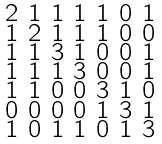Convert formula to latex. <formula><loc_0><loc_0><loc_500><loc_500>\begin{smallmatrix} 2 & 1 & 1 & 1 & 1 & 0 & 1 \\ 1 & 2 & 1 & 1 & 1 & 0 & 0 \\ 1 & 1 & 3 & 1 & 0 & 0 & 1 \\ 1 & 1 & 1 & 3 & 0 & 0 & 1 \\ 1 & 1 & 0 & 0 & 3 & 1 & 0 \\ 0 & 0 & 0 & 0 & 1 & 3 & 1 \\ 1 & 0 & 1 & 1 & 0 & 1 & 3 \end{smallmatrix}</formula> 